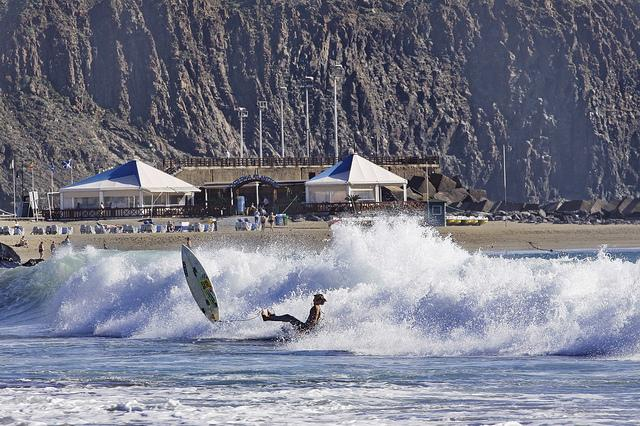Why is he not on the surfboard? fell off 